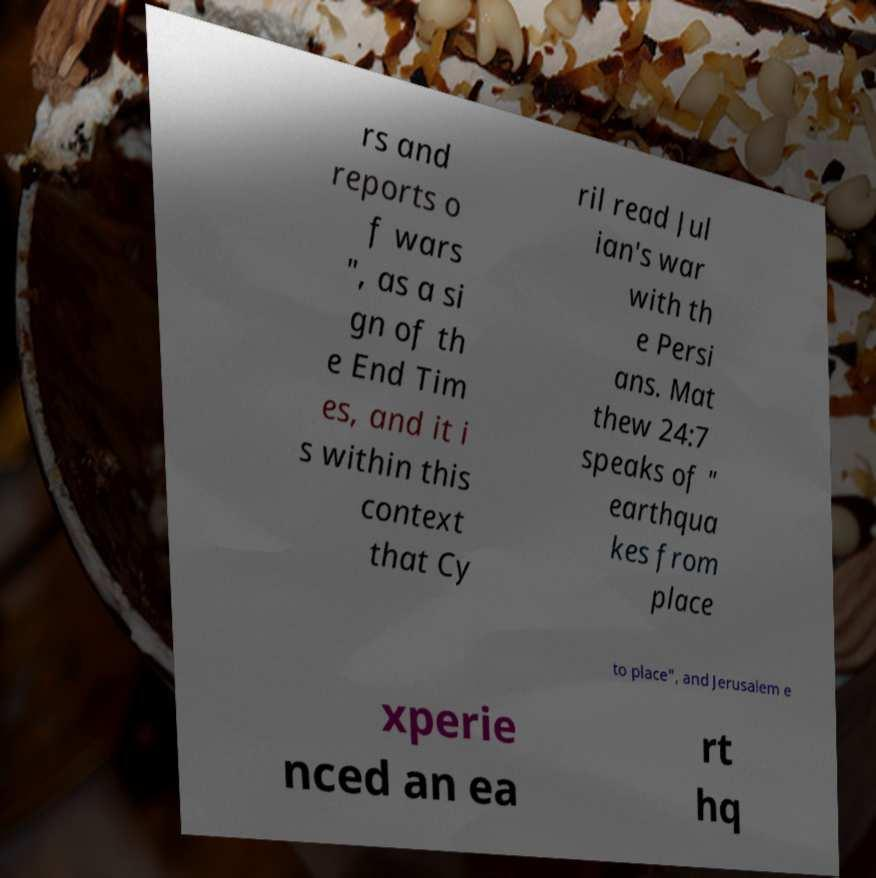Please read and relay the text visible in this image. What does it say? rs and reports o f wars ", as a si gn of th e End Tim es, and it i s within this context that Cy ril read Jul ian's war with th e Persi ans. Mat thew 24:7 speaks of " earthqua kes from place to place", and Jerusalem e xperie nced an ea rt hq 